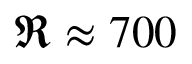Convert formula to latex. <formula><loc_0><loc_0><loc_500><loc_500>\Re \approx 7 0 0</formula> 